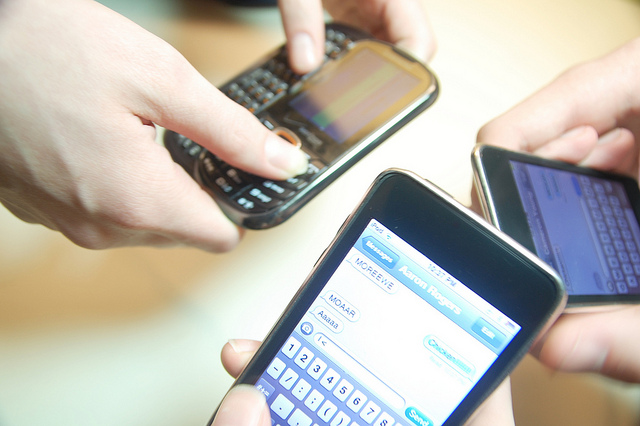Identify the text displayed in this image. 4 MOREEWE MOAAR 2 3 5 6 7 